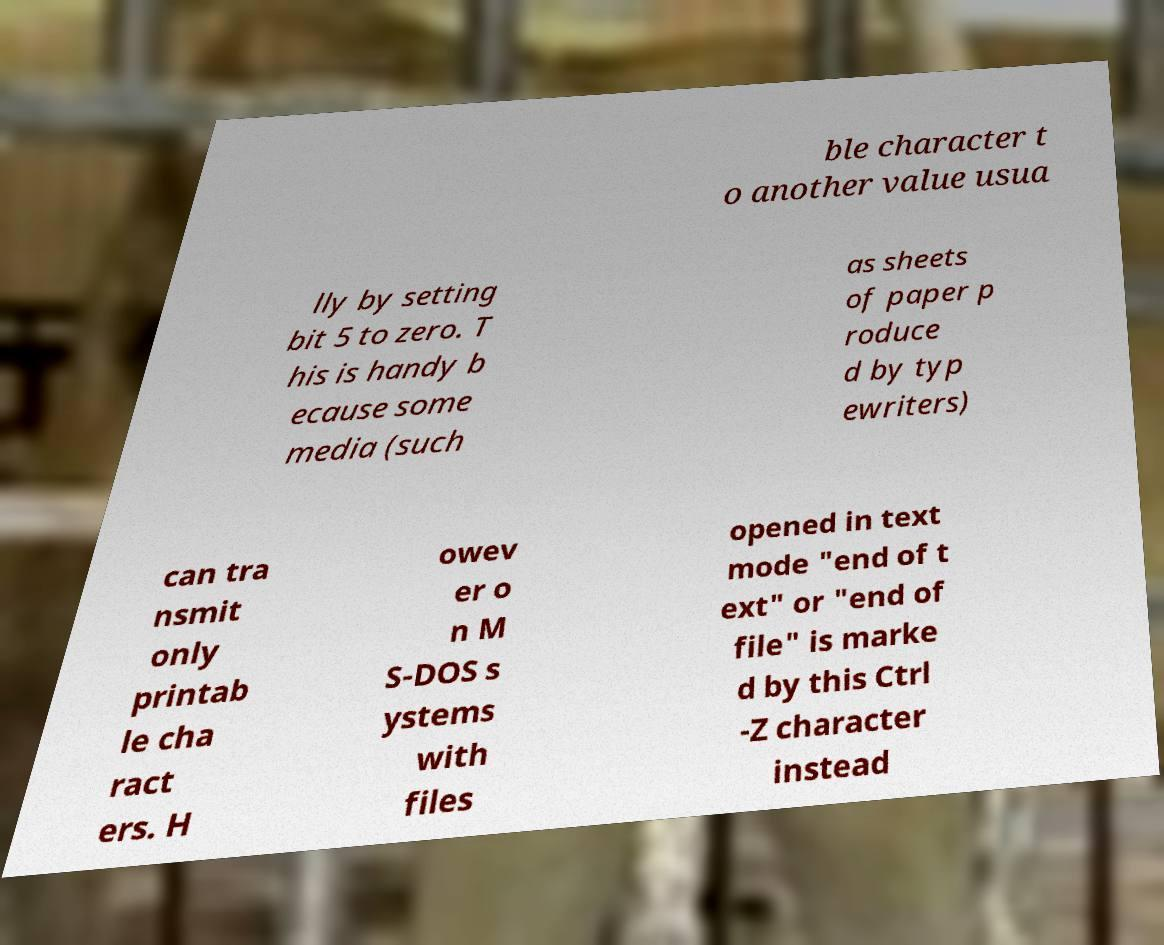Could you extract and type out the text from this image? ble character t o another value usua lly by setting bit 5 to zero. T his is handy b ecause some media (such as sheets of paper p roduce d by typ ewriters) can tra nsmit only printab le cha ract ers. H owev er o n M S-DOS s ystems with files opened in text mode "end of t ext" or "end of file" is marke d by this Ctrl -Z character instead 